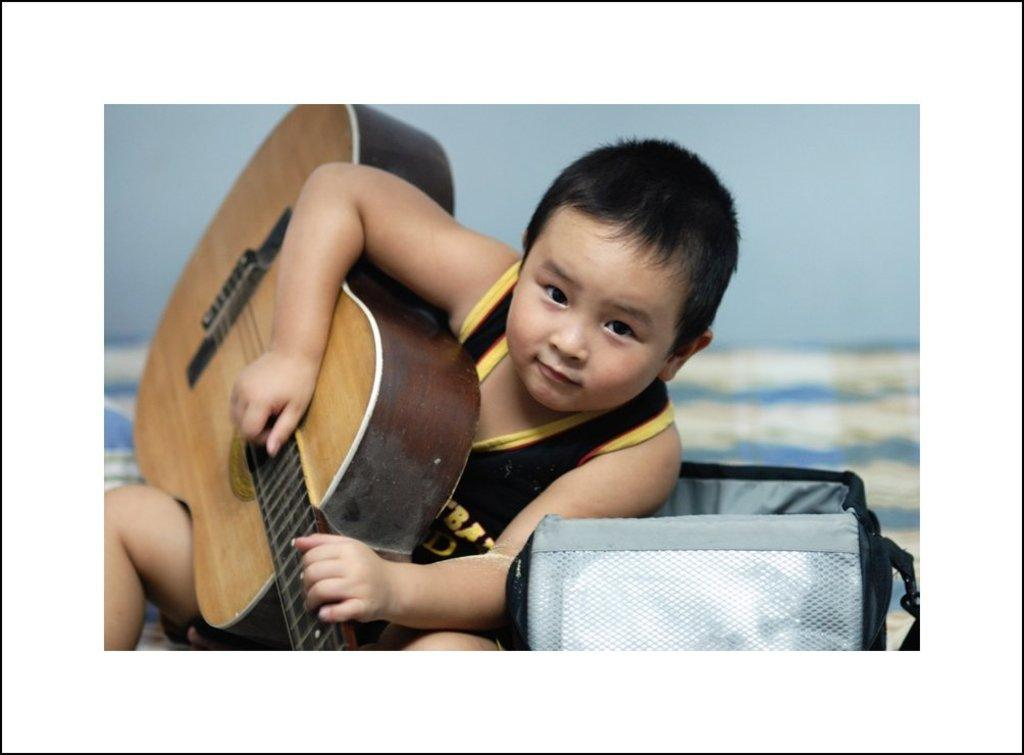What is the main subject of the image? There is a child in the image. What is the child holding in the image? The child is holding a guitar. Can you describe any other objects or features in the image? There is a basket behind the child. How many feet of dirt can be seen in the image? There is no dirt visible in the image, so it is not possible to determine the number of feet of dirt. 